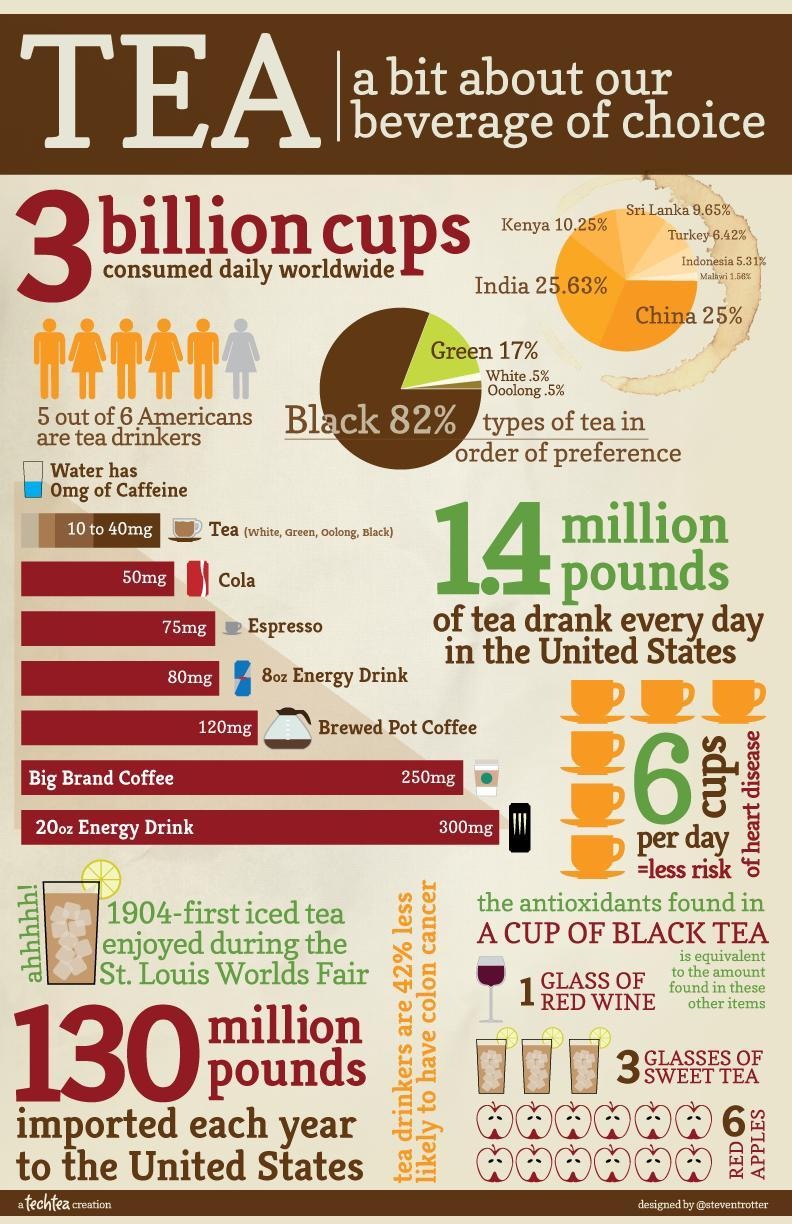What amount of caffeine is present in Cola?
Answer the question with a short phrase. 50mg Which type of tea is consumed by majority of people in America? Black What percentage of people in India are tea drinkers? 25.63% What percentage of Americans are green tea drinkers? 17% What percentage of Americans are white tea drinkers? .5% Which drink has 250mg of caffeine present in it? Big Brand Coffee What amount of caffeine is present in brewed pot coffee? 120mg 